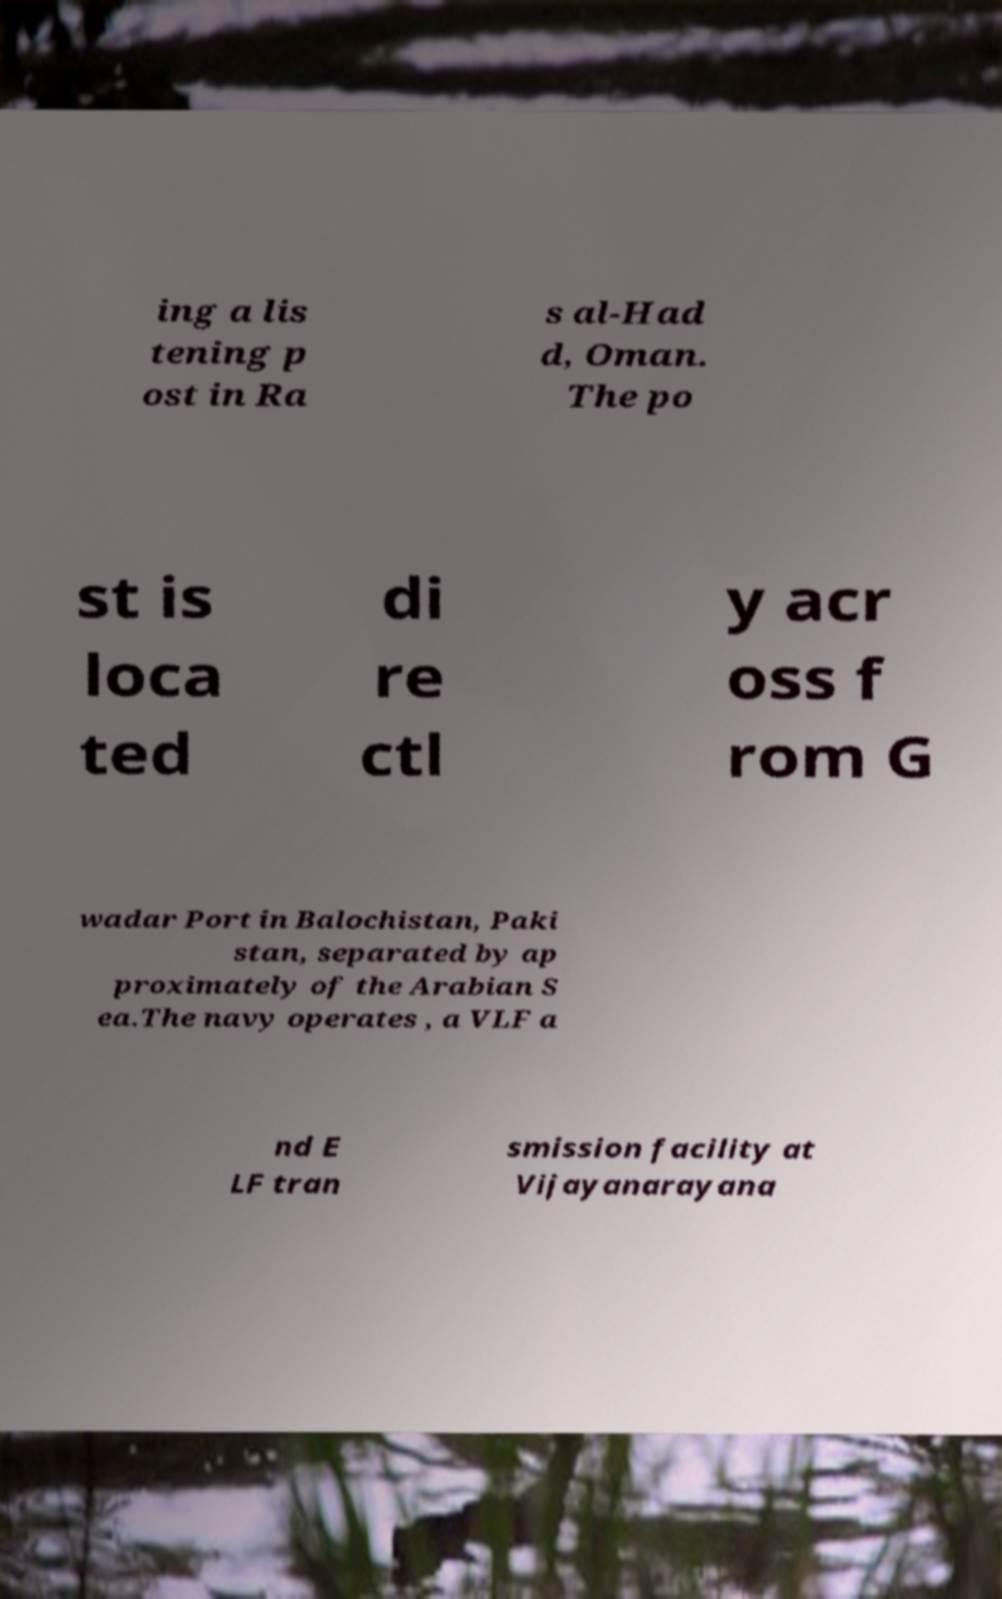Could you assist in decoding the text presented in this image and type it out clearly? ing a lis tening p ost in Ra s al-Had d, Oman. The po st is loca ted di re ctl y acr oss f rom G wadar Port in Balochistan, Paki stan, separated by ap proximately of the Arabian S ea.The navy operates , a VLF a nd E LF tran smission facility at Vijayanarayana 